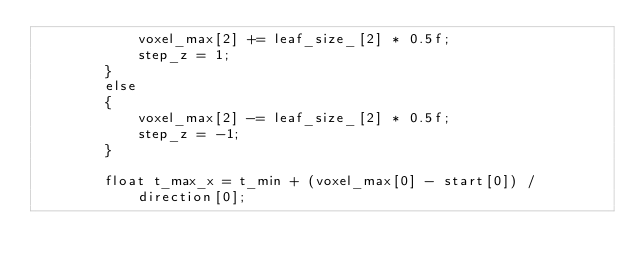Convert code to text. <code><loc_0><loc_0><loc_500><loc_500><_Cuda_>            voxel_max[2] += leaf_size_[2] * 0.5f;
            step_z = 1;
        }
        else
        {
            voxel_max[2] -= leaf_size_[2] * 0.5f;
            step_z = -1;
        }

        float t_max_x = t_min + (voxel_max[0] - start[0]) / direction[0];</code> 